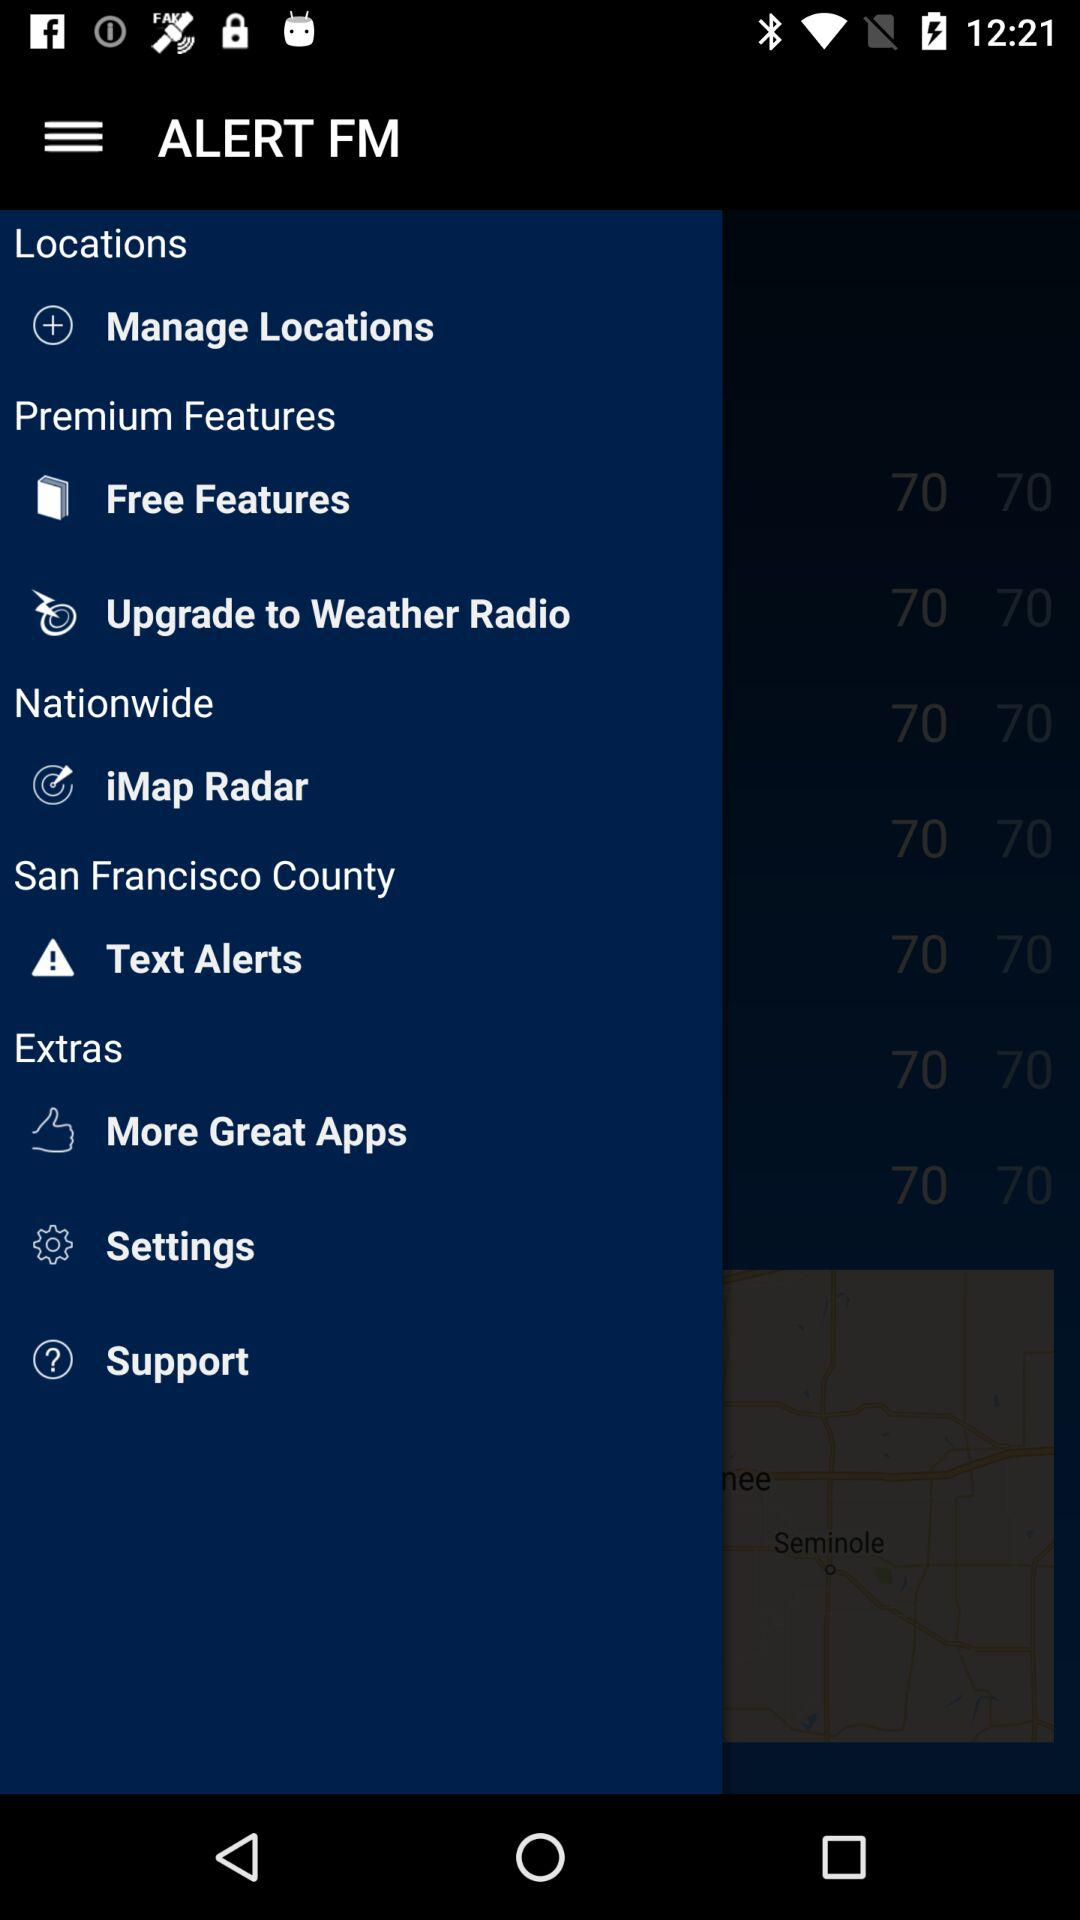What is the city name? The city name is San Francisco. 